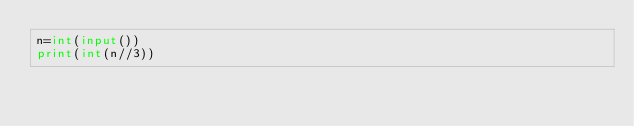Convert code to text. <code><loc_0><loc_0><loc_500><loc_500><_Python_>n=int(input())
print(int(n//3))
</code> 